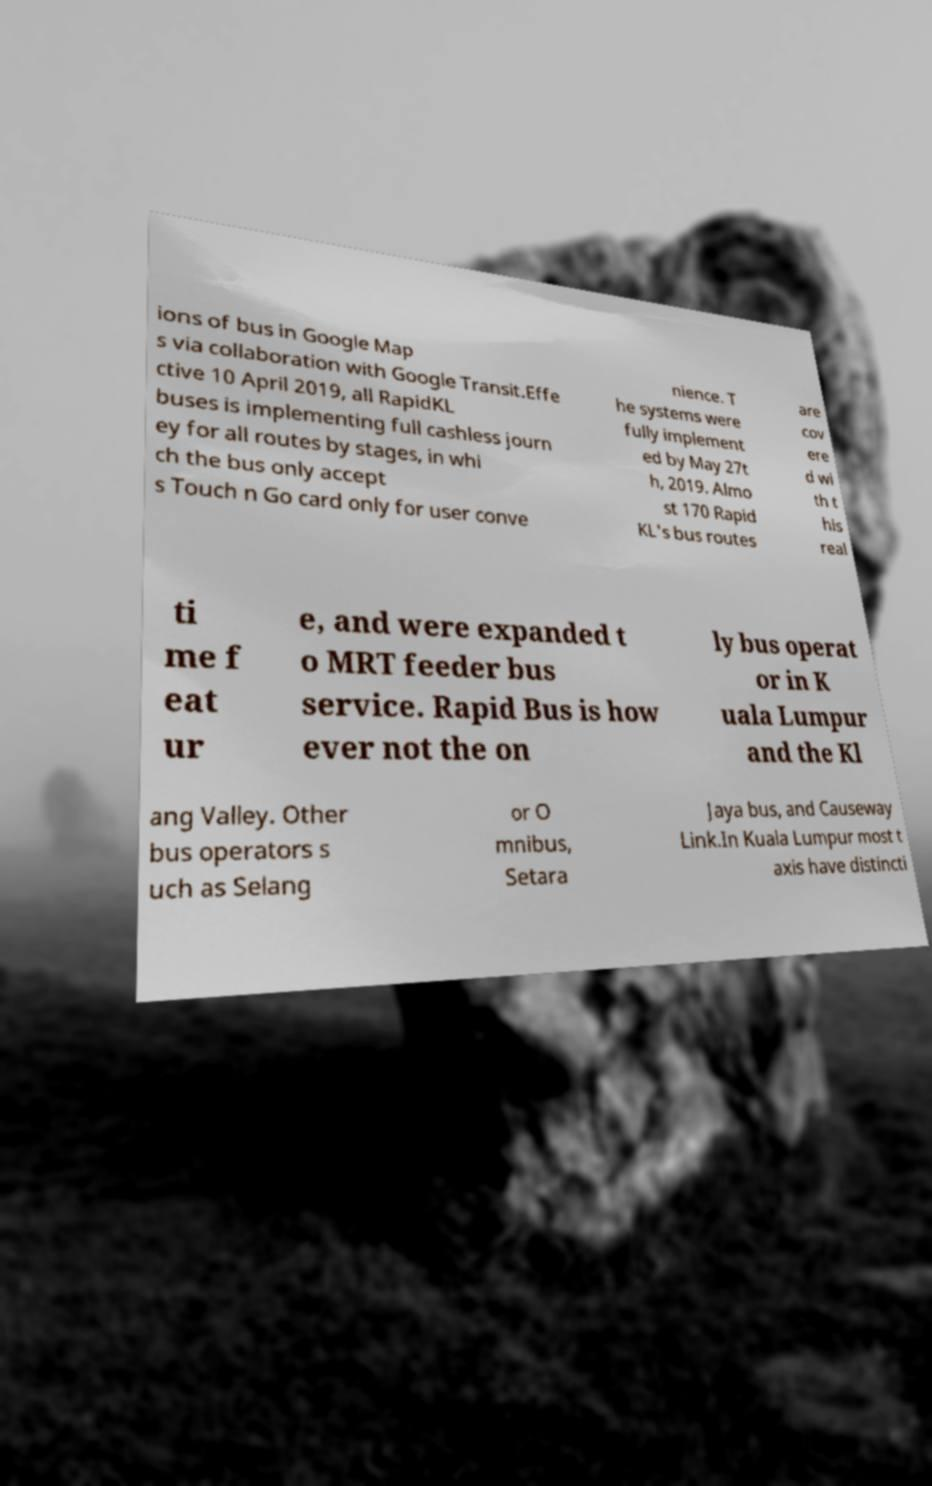Please identify and transcribe the text found in this image. ions of bus in Google Map s via collaboration with Google Transit.Effe ctive 10 April 2019, all RapidKL buses is implementing full cashless journ ey for all routes by stages, in whi ch the bus only accept s Touch n Go card only for user conve nience. T he systems were fully implement ed by May 27t h, 2019. Almo st 170 Rapid KL's bus routes are cov ere d wi th t his real ti me f eat ur e, and were expanded t o MRT feeder bus service. Rapid Bus is how ever not the on ly bus operat or in K uala Lumpur and the Kl ang Valley. Other bus operators s uch as Selang or O mnibus, Setara Jaya bus, and Causeway Link.In Kuala Lumpur most t axis have distincti 